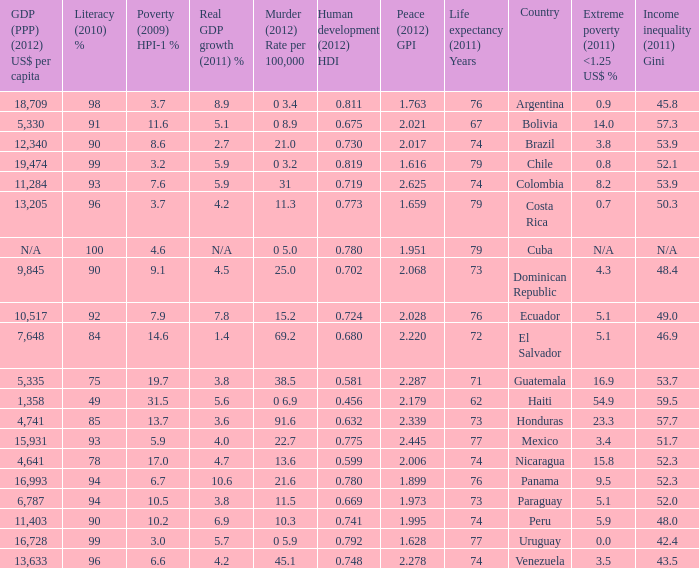What is the total poverty (2009) HPI-1 % when the extreme poverty (2011) <1.25 US$ % of 16.9, and the human development (2012) HDI is less than 0.581? None. Give me the full table as a dictionary. {'header': ['GDP (PPP) (2012) US$ per capita', 'Literacy (2010) %', 'Poverty (2009) HPI-1 %', 'Real GDP growth (2011) %', 'Murder (2012) Rate per 100,000', 'Human development (2012) HDI', 'Peace (2012) GPI', 'Life expectancy (2011) Years', 'Country', 'Extreme poverty (2011) <1.25 US$ %', 'Income inequality (2011) Gini'], 'rows': [['18,709', '98', '3.7', '8.9', '0 3.4', '0.811', '1.763', '76', 'Argentina', '0.9', '45.8'], ['5,330', '91', '11.6', '5.1', '0 8.9', '0.675', '2.021', '67', 'Bolivia', '14.0', '57.3'], ['12,340', '90', '8.6', '2.7', '21.0', '0.730', '2.017', '74', 'Brazil', '3.8', '53.9'], ['19,474', '99', '3.2', '5.9', '0 3.2', '0.819', '1.616', '79', 'Chile', '0.8', '52.1'], ['11,284', '93', '7.6', '5.9', '31', '0.719', '2.625', '74', 'Colombia', '8.2', '53.9'], ['13,205', '96', '3.7', '4.2', '11.3', '0.773', '1.659', '79', 'Costa Rica', '0.7', '50.3'], ['N/A', '100', '4.6', 'N/A', '0 5.0', '0.780', '1.951', '79', 'Cuba', 'N/A', 'N/A'], ['9,845', '90', '9.1', '4.5', '25.0', '0.702', '2.068', '73', 'Dominican Republic', '4.3', '48.4'], ['10,517', '92', '7.9', '7.8', '15.2', '0.724', '2.028', '76', 'Ecuador', '5.1', '49.0'], ['7,648', '84', '14.6', '1.4', '69.2', '0.680', '2.220', '72', 'El Salvador', '5.1', '46.9'], ['5,335', '75', '19.7', '3.8', '38.5', '0.581', '2.287', '71', 'Guatemala', '16.9', '53.7'], ['1,358', '49', '31.5', '5.6', '0 6.9', '0.456', '2.179', '62', 'Haiti', '54.9', '59.5'], ['4,741', '85', '13.7', '3.6', '91.6', '0.632', '2.339', '73', 'Honduras', '23.3', '57.7'], ['15,931', '93', '5.9', '4.0', '22.7', '0.775', '2.445', '77', 'Mexico', '3.4', '51.7'], ['4,641', '78', '17.0', '4.7', '13.6', '0.599', '2.006', '74', 'Nicaragua', '15.8', '52.3'], ['16,993', '94', '6.7', '10.6', '21.6', '0.780', '1.899', '76', 'Panama', '9.5', '52.3'], ['6,787', '94', '10.5', '3.8', '11.5', '0.669', '1.973', '73', 'Paraguay', '5.1', '52.0'], ['11,403', '90', '10.2', '6.9', '10.3', '0.741', '1.995', '74', 'Peru', '5.9', '48.0'], ['16,728', '99', '3.0', '5.7', '0 5.9', '0.792', '1.628', '77', 'Uruguay', '0.0', '42.4'], ['13,633', '96', '6.6', '4.2', '45.1', '0.748', '2.278', '74', 'Venezuela', '3.5', '43.5']]} 